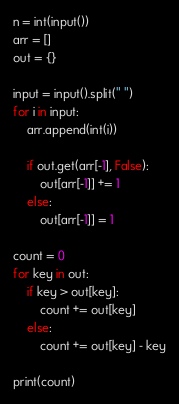Convert code to text. <code><loc_0><loc_0><loc_500><loc_500><_Python_>n = int(input())
arr = []
out = {}

input = input().split(" ")
for i in input:
	arr.append(int(i))
	
	if out.get(arr[-1], False):
		out[arr[-1]] += 1
	else:
		out[arr[-1]] = 1

count = 0
for key in out:
	if key > out[key]:
		count += out[key]
	else:
		count += out[key] - key

print(count)</code> 